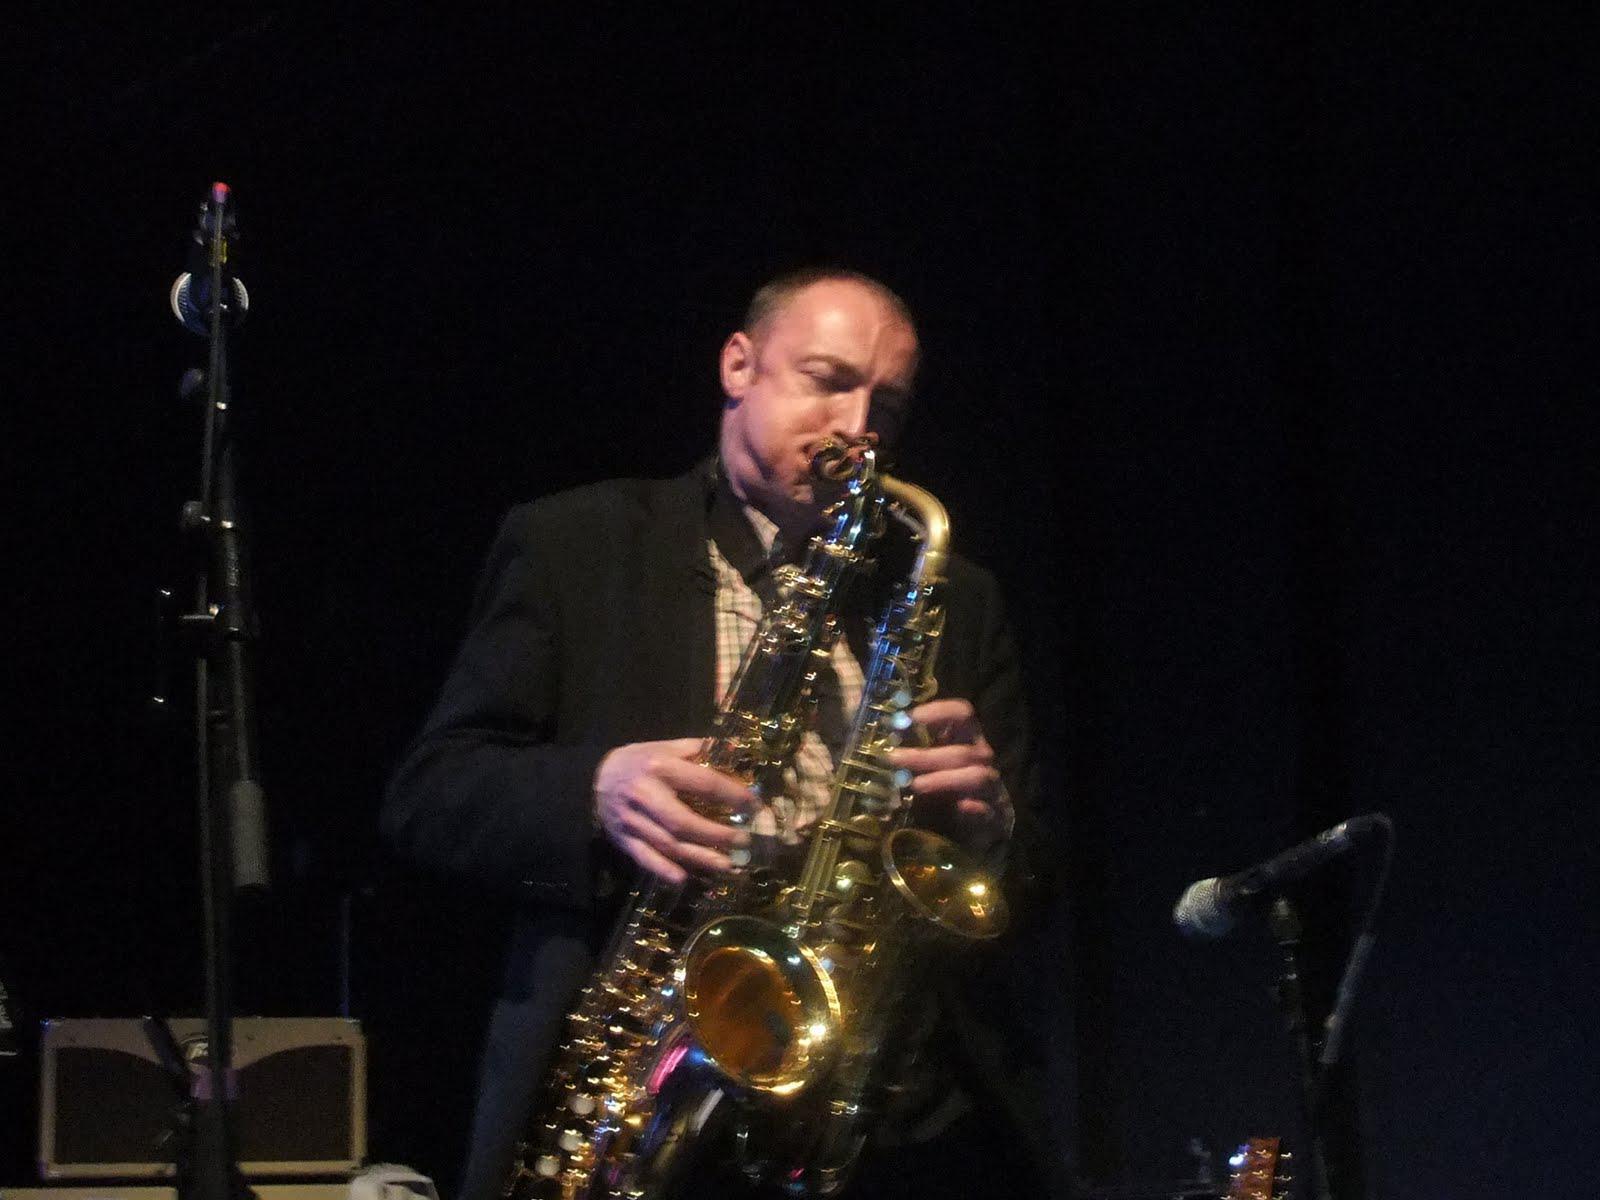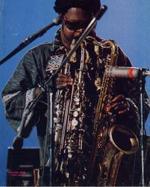The first image is the image on the left, the second image is the image on the right. Evaluate the accuracy of this statement regarding the images: "A man in a dark hat and dark glasses is playing two saxophones simultaneously.". Is it true? Answer yes or no. Yes. The first image is the image on the left, the second image is the image on the right. Assess this claim about the two images: "Two men are in front of microphones, one playing two saxophones and one playing three, with no other persons seen playing any instruments.". Correct or not? Answer yes or no. Yes. 